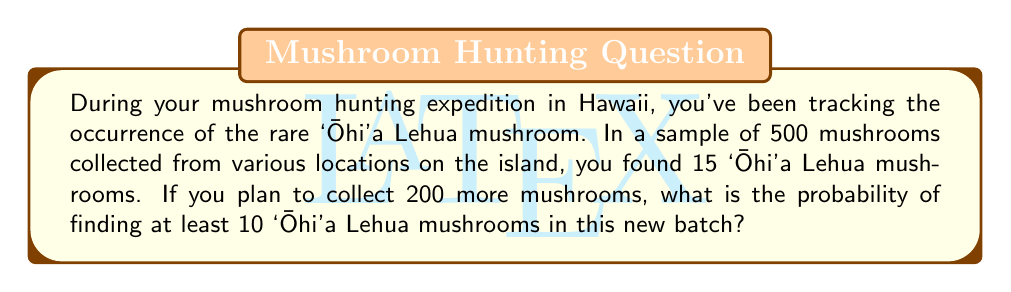Provide a solution to this math problem. Let's approach this step-by-step using the binomial probability distribution:

1. First, we need to calculate the probability of finding an 'Ōhi'a Lehua mushroom based on the given data:
   $p = \frac{15}{500} = 0.03$

2. We want to find the probability of finding at least 10 'Ōhi'a Lehua mushrooms in 200 trials. This is equivalent to finding the probability of 10 or more successes:
   $P(X \geq 10)$, where $X$ follows a binomial distribution with $n=200$ and $p=0.03$

3. We can calculate this by subtracting the probability of finding 9 or fewer from 1:
   $P(X \geq 10) = 1 - P(X \leq 9)$

4. The probability mass function for a binomial distribution is:
   $P(X = k) = \binom{n}{k} p^k (1-p)^{n-k}$

5. We need to sum this for $k = 0$ to $9$:
   $P(X \leq 9) = \sum_{k=0}^{9} \binom{200}{k} (0.03)^k (0.97)^{200-k}$

6. This sum is tedious to calculate by hand, so we would typically use statistical software or a calculator. Using such tools, we find:
   $P(X \leq 9) \approx 0.0584$

7. Therefore, the probability of finding at least 10 'Ōhi'a Lehua mushrooms is:
   $P(X \geq 10) = 1 - 0.0584 \approx 0.9416$
Answer: $0.9416$ or $94.16\%$ 